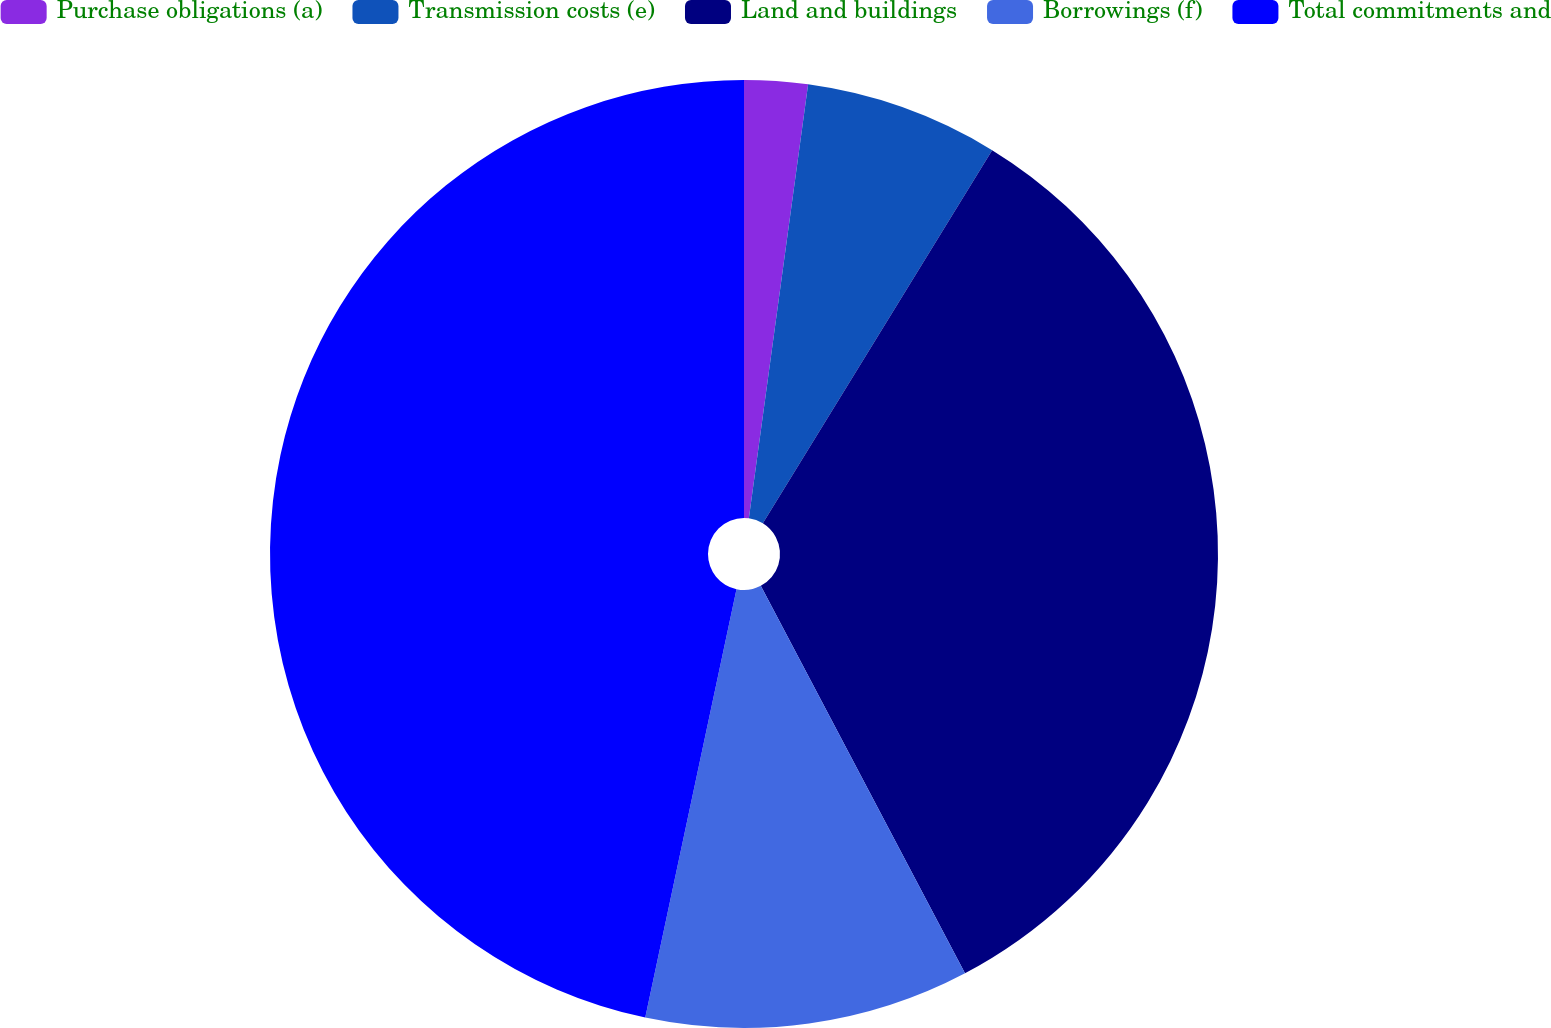<chart> <loc_0><loc_0><loc_500><loc_500><pie_chart><fcel>Purchase obligations (a)<fcel>Transmission costs (e)<fcel>Land and buildings<fcel>Borrowings (f)<fcel>Total commitments and<nl><fcel>2.16%<fcel>6.61%<fcel>33.51%<fcel>11.06%<fcel>46.66%<nl></chart> 